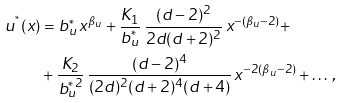<formula> <loc_0><loc_0><loc_500><loc_500>u ^ { ^ { * } } ( x ) & = b _ { u } ^ { * } \, x ^ { \beta _ { u } } + \frac { K _ { 1 } } { b _ { u } ^ { * } } \, \frac { ( d - 2 ) ^ { 2 } } { 2 d ( d + 2 ) ^ { 2 } } \, x ^ { - ( \beta _ { u } - 2 ) } + \\ & + \frac { K _ { 2 } } { b _ { u } ^ { * \, 2 } } \, \frac { ( d - 2 ) ^ { 4 } } { ( 2 d ) ^ { 2 } ( d + 2 ) ^ { 4 } ( d + 4 ) } \, x ^ { - 2 ( \beta _ { u } - 2 ) } + \dots \, ,</formula> 